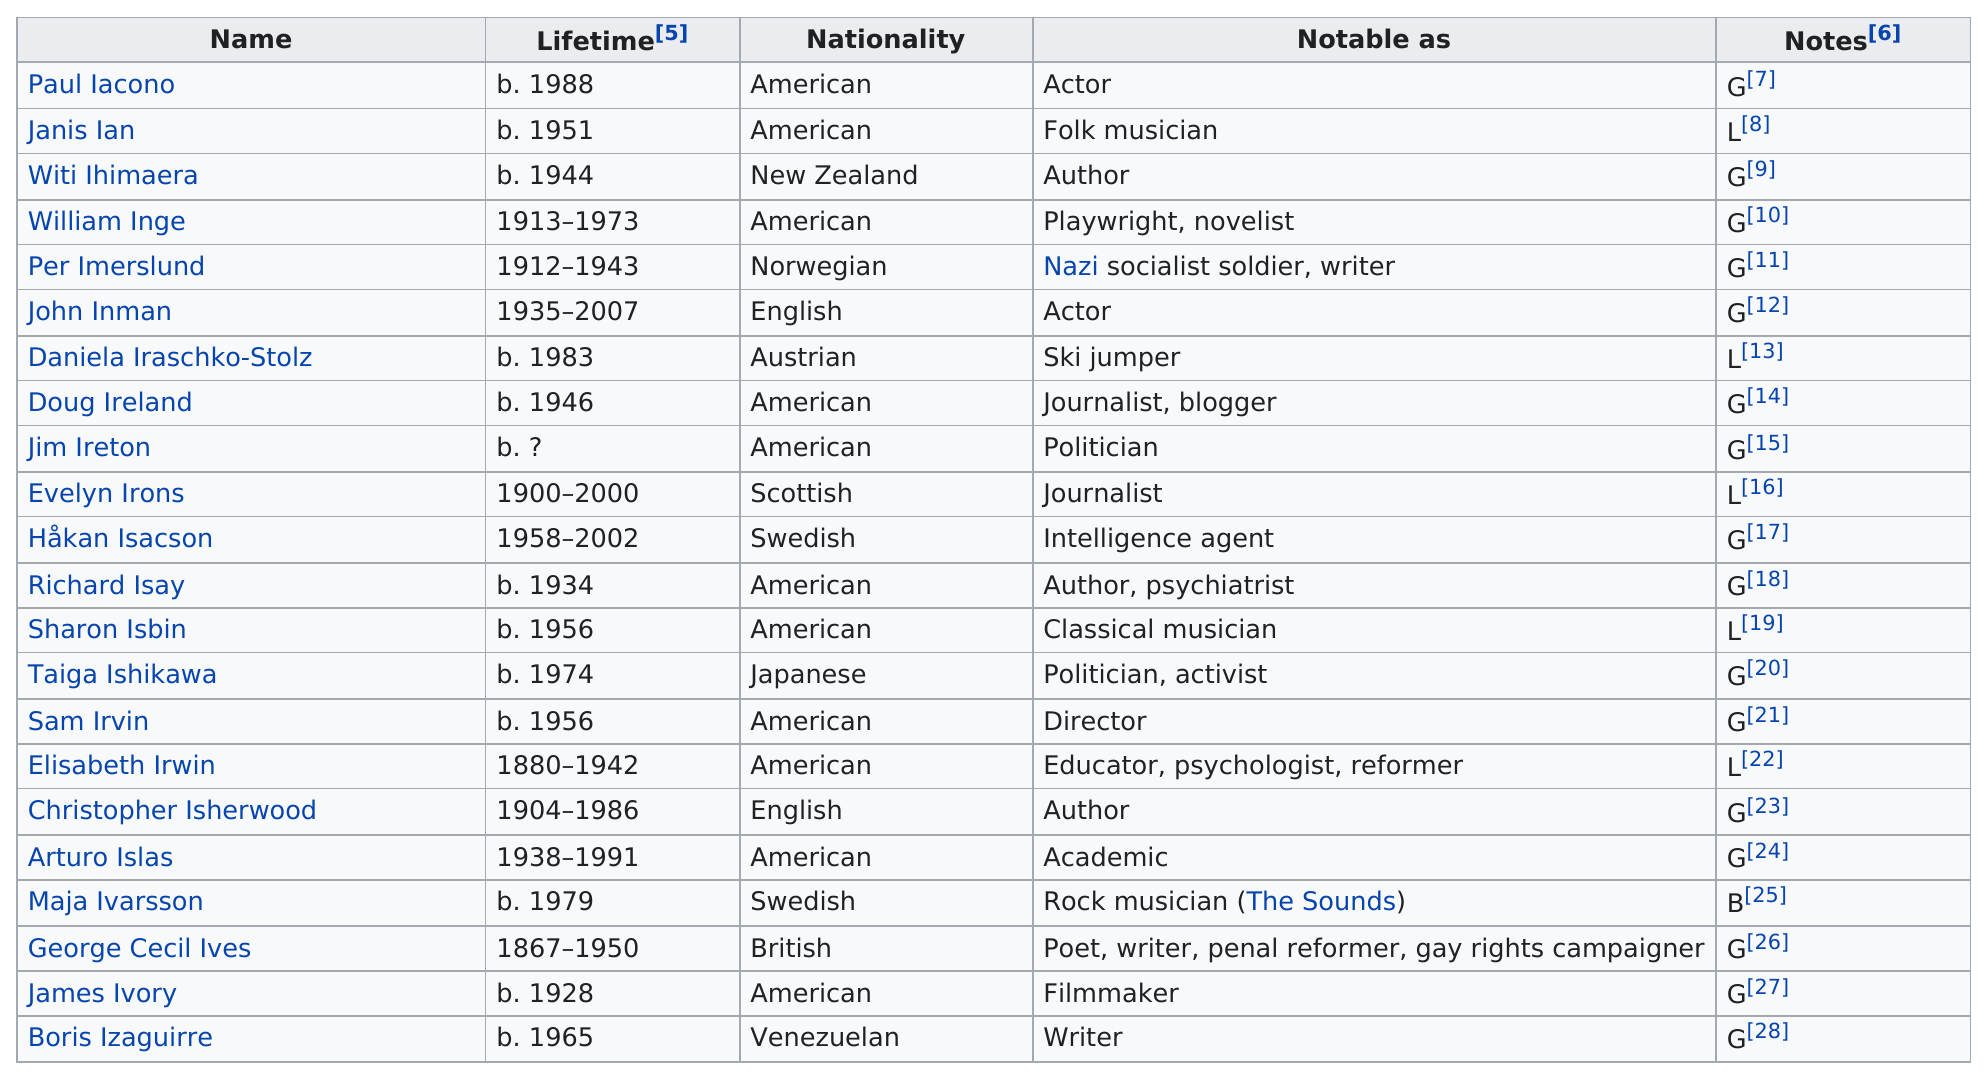List a handful of essential elements in this visual. Evelyn Irons is the longest living lesbian on the list. There is a famous person with a last name from the range of i-j who is gay, lesbian, or bisexual and is currently the oldest living person of that group. Their name is Richard Isay. Doug Ireland was an American who made notable contributions as a journalist and blogger. Maja Ivarsson is from the same country as Håkan Isacson, a famous person who identifies as gay, lesbian, or bisexual. It is estimated that approximately 3 lesbians were born after 1950. 